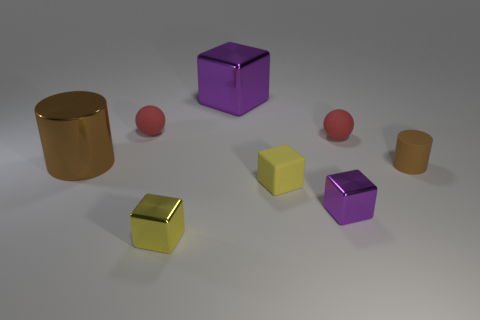What is the brown thing right of the big brown cylinder made of?
Provide a short and direct response. Rubber. Are there any small brown matte objects on the right side of the large purple shiny block?
Give a very brief answer. Yes. The brown metallic object is what shape?
Give a very brief answer. Cylinder. How many objects are tiny matte spheres behind the big metal cylinder or big blue metal cubes?
Offer a very short reply. 2. How many other things are there of the same color as the large metal cylinder?
Provide a succinct answer. 1. There is a metal cylinder; does it have the same color as the cylinder that is in front of the brown shiny thing?
Give a very brief answer. Yes. What is the color of the tiny matte thing that is the same shape as the small purple metal thing?
Your answer should be compact. Yellow. Is the large brown thing made of the same material as the small yellow thing left of the big purple metal thing?
Offer a very short reply. Yes. What is the color of the small matte cylinder?
Make the answer very short. Brown. There is a tiny ball on the left side of the purple metallic block that is behind the cylinder that is in front of the large brown shiny cylinder; what is its color?
Your response must be concise. Red. 